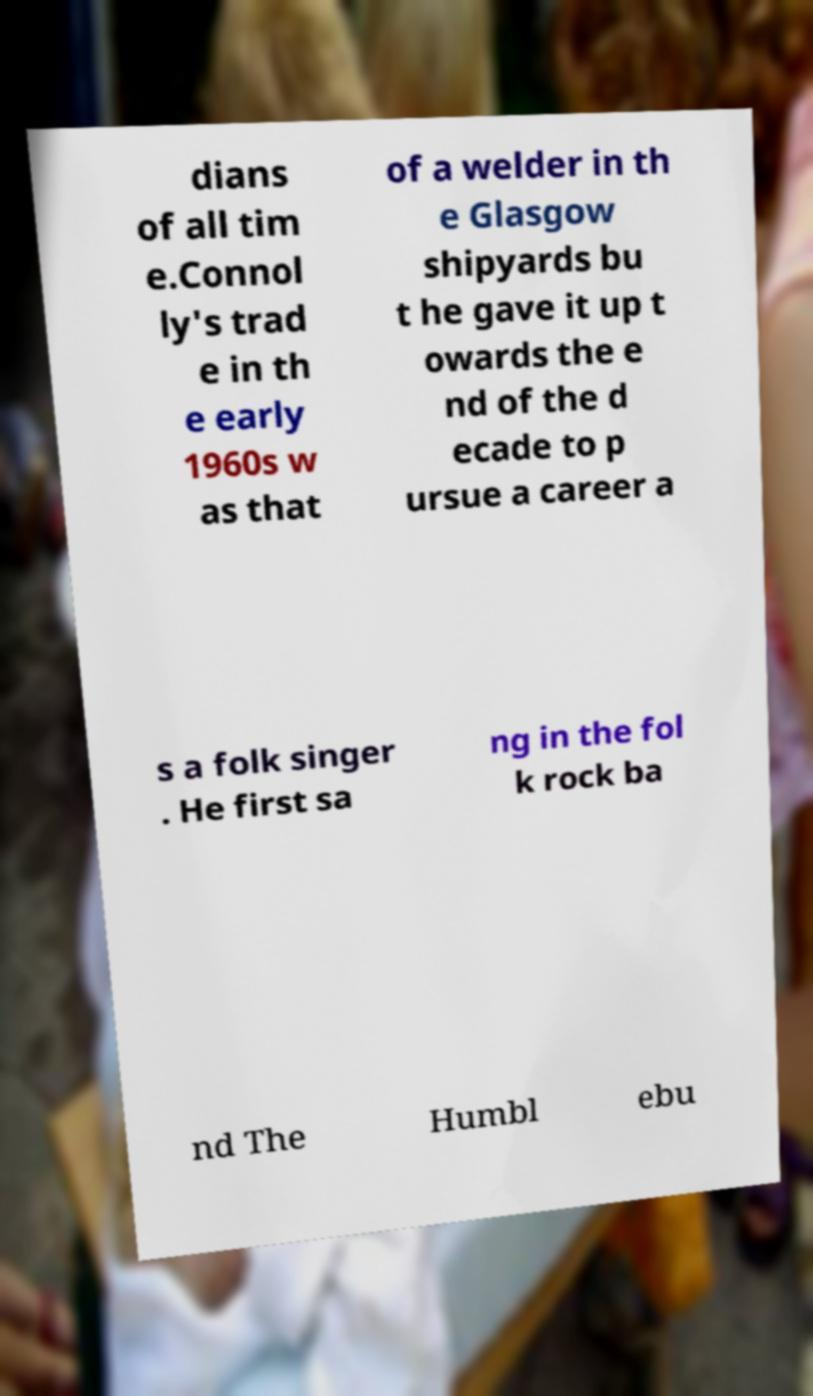Can you read and provide the text displayed in the image?This photo seems to have some interesting text. Can you extract and type it out for me? dians of all tim e.Connol ly's trad e in th e early 1960s w as that of a welder in th e Glasgow shipyards bu t he gave it up t owards the e nd of the d ecade to p ursue a career a s a folk singer . He first sa ng in the fol k rock ba nd The Humbl ebu 